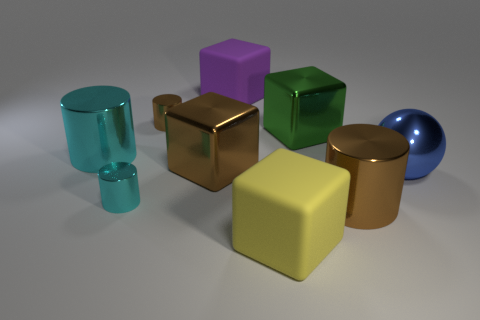Subtract all small brown cylinders. How many cylinders are left? 3 Subtract all green blocks. How many brown cylinders are left? 2 Subtract 2 cubes. How many cubes are left? 2 Add 1 blue metallic balls. How many objects exist? 10 Subtract all blue blocks. Subtract all red balls. How many blocks are left? 4 Subtract all spheres. How many objects are left? 8 Subtract all big green shiny things. Subtract all large green cubes. How many objects are left? 7 Add 9 purple rubber things. How many purple rubber things are left? 10 Add 5 green blocks. How many green blocks exist? 6 Subtract 0 red spheres. How many objects are left? 9 